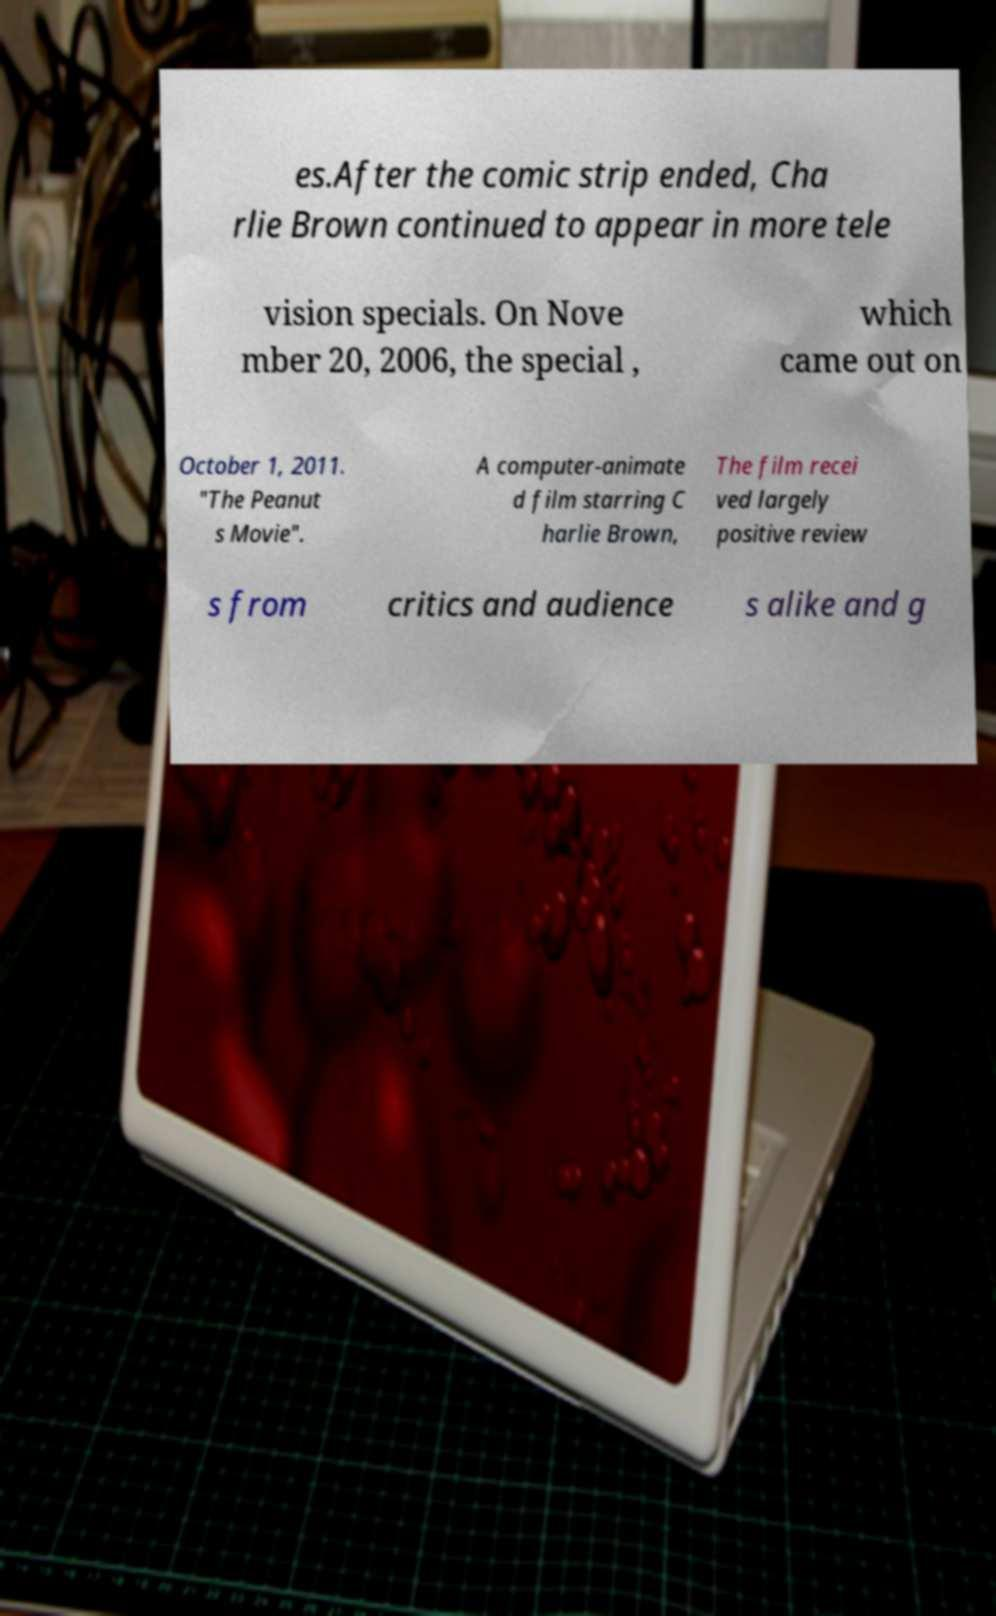Please identify and transcribe the text found in this image. es.After the comic strip ended, Cha rlie Brown continued to appear in more tele vision specials. On Nove mber 20, 2006, the special , which came out on October 1, 2011. "The Peanut s Movie". A computer-animate d film starring C harlie Brown, The film recei ved largely positive review s from critics and audience s alike and g 